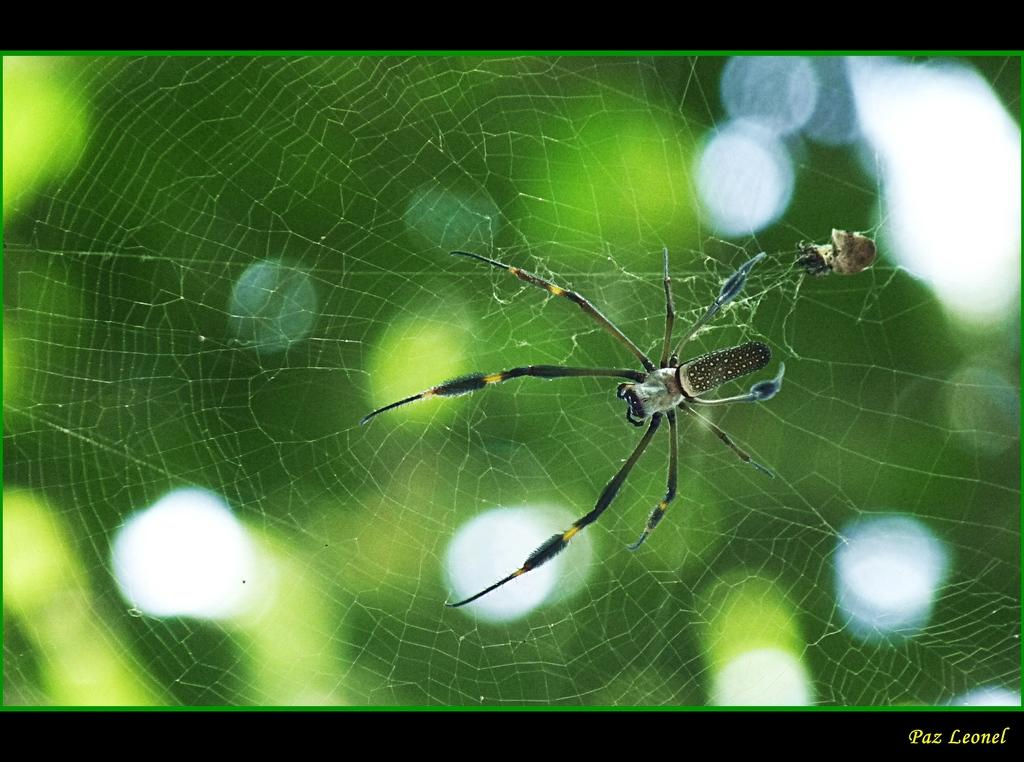What is the main subject of the image? The main subject of the image is a spider. Where is the spider located in the image? The spider is on a spider web. What can be seen in the background of the image? There are plants visible in the background of the image, although they are not clearly visible. What type of toys can be seen in the image? There are no toys present in the image; it features a spider on a spider web. Is there a stranger in the image? There is no stranger present in the image; it features a spider on a spider web. 